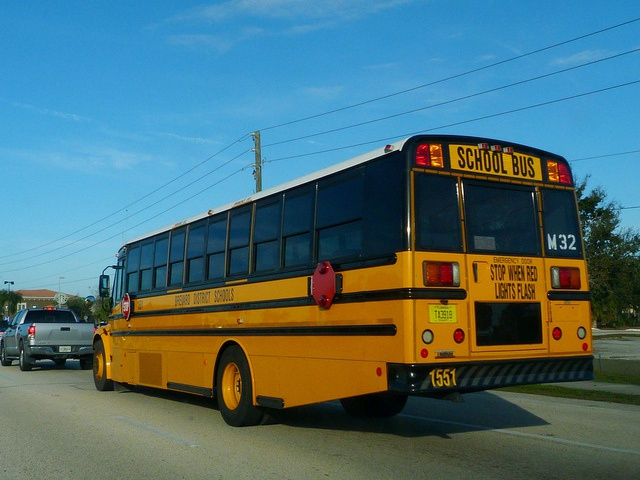Describe the objects in this image and their specific colors. I can see bus in gray, black, olive, darkblue, and blue tones, truck in gray, black, teal, and purple tones, and stop sign in gray, maroon, darkgray, and brown tones in this image. 